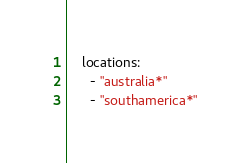Convert code to text. <code><loc_0><loc_0><loc_500><loc_500><_YAML_>    locations:
      - "australia*"
      - "southamerica*"</code> 